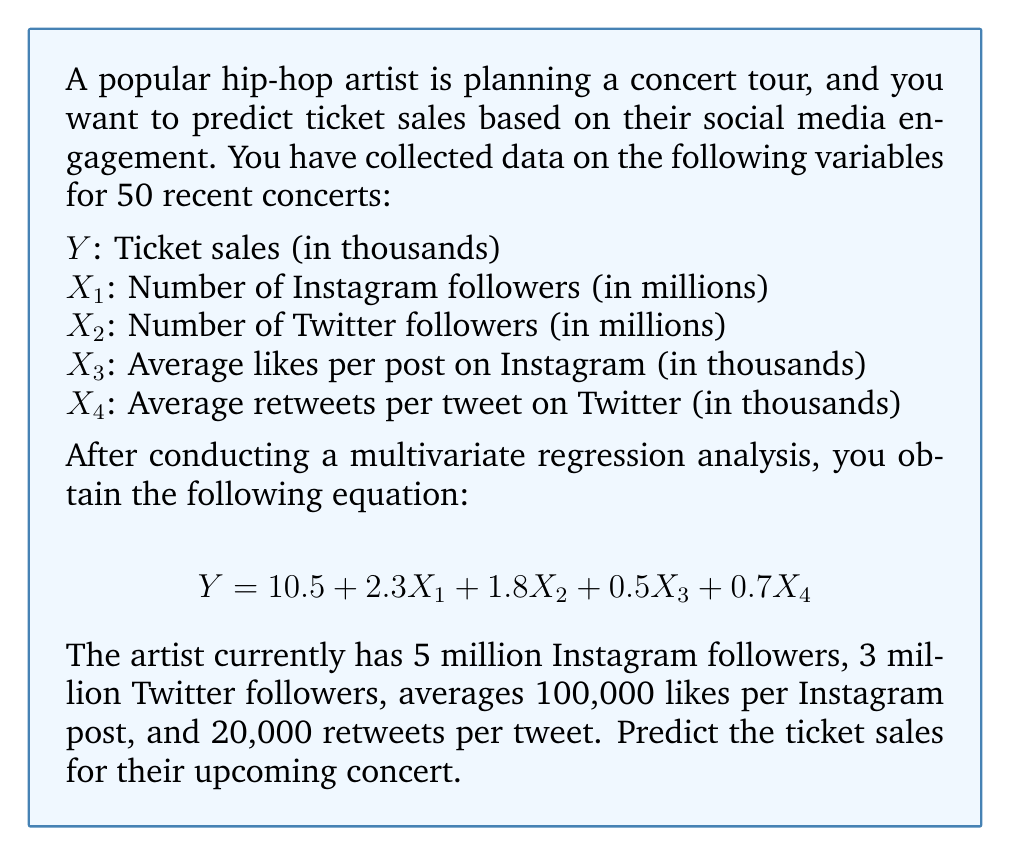Could you help me with this problem? To solve this problem, we need to use the multivariate regression equation provided and substitute the given values for each variable. Let's break it down step by step:

1. Recall the regression equation:
   $$Y = 10.5 + 2.3X_1 + 1.8X_2 + 0.5X_3 + 0.7X_4$$

2. We have the following values:
   $X_1 = 5$ (5 million Instagram followers)
   $X_2 = 3$ (3 million Twitter followers)
   $X_3 = 100$ (100,000 likes per Instagram post)
   $X_4 = 20$ (20,000 retweets per tweet)

3. Let's substitute these values into the equation:
   $$Y = 10.5 + 2.3(5) + 1.8(3) + 0.5(100) + 0.7(20)$$

4. Now, let's calculate each term:
   $$Y = 10.5 + 11.5 + 5.4 + 50 + 14$$

5. Finally, sum up all the terms:
   $$Y = 91.4$$

Therefore, the predicted ticket sales for the upcoming concert are 91.4 thousand, or 91,400 tickets.
Answer: 91.4 thousand tickets (or 91,400 tickets) 